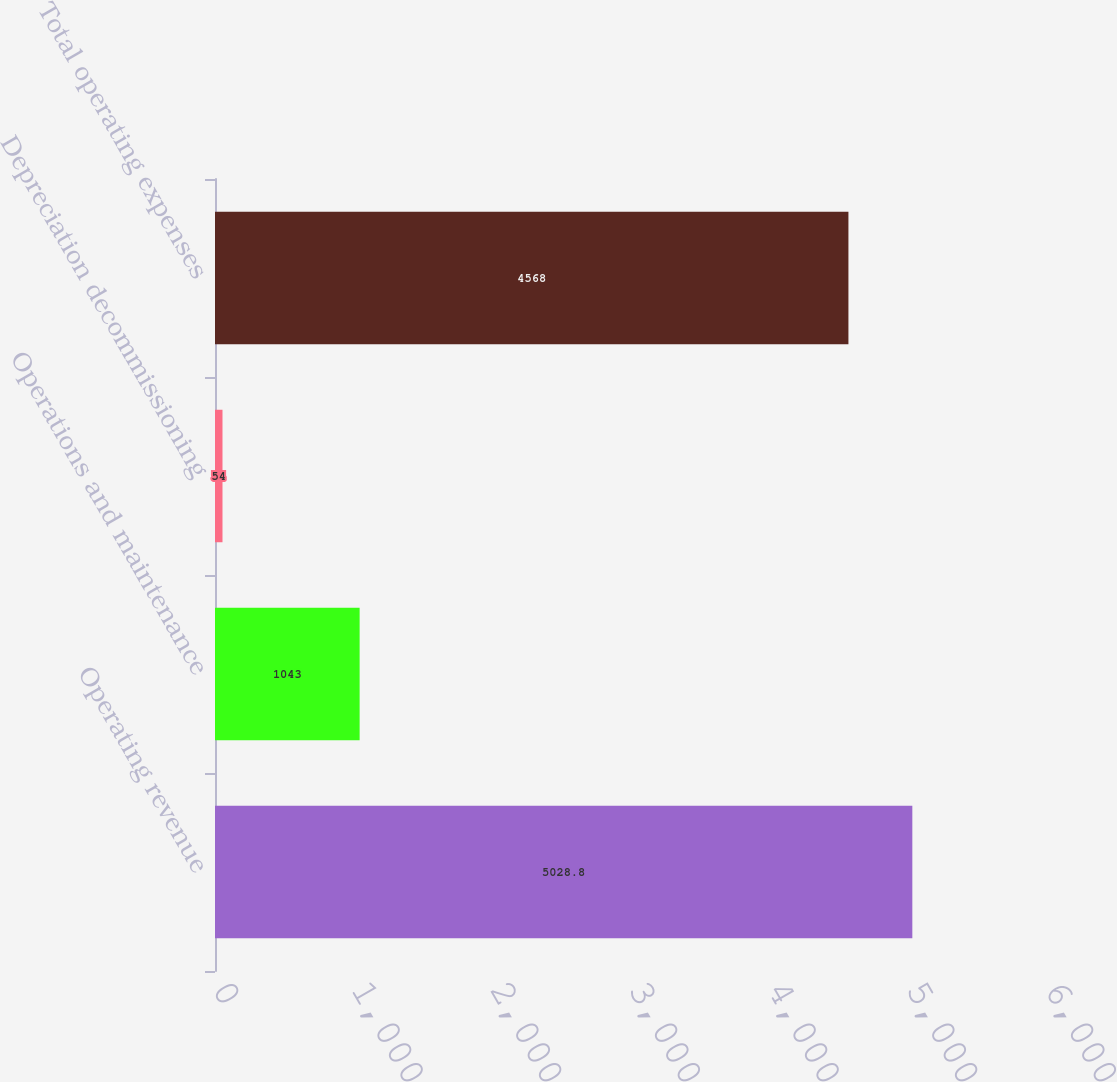<chart> <loc_0><loc_0><loc_500><loc_500><bar_chart><fcel>Operating revenue<fcel>Operations and maintenance<fcel>Depreciation decommissioning<fcel>Total operating expenses<nl><fcel>5028.8<fcel>1043<fcel>54<fcel>4568<nl></chart> 